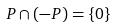Convert formula to latex. <formula><loc_0><loc_0><loc_500><loc_500>P \cap ( - P ) = \{ 0 \}</formula> 